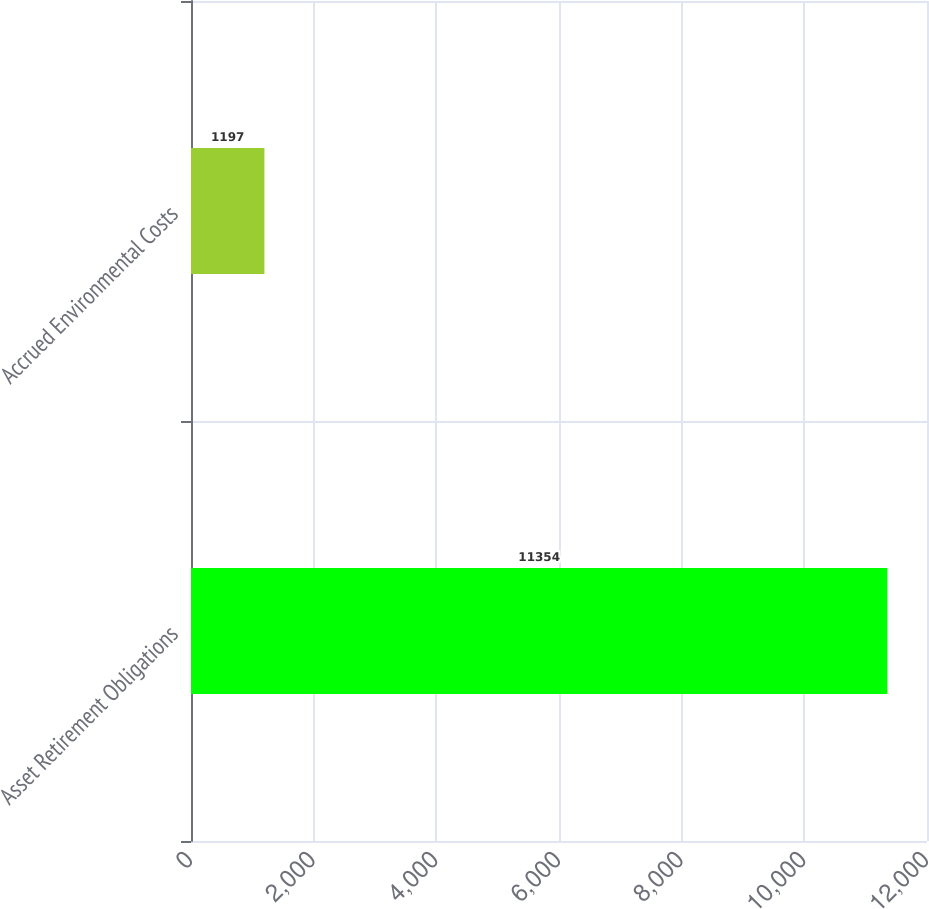<chart> <loc_0><loc_0><loc_500><loc_500><bar_chart><fcel>Asset Retirement Obligations<fcel>Accrued Environmental Costs<nl><fcel>11354<fcel>1197<nl></chart> 